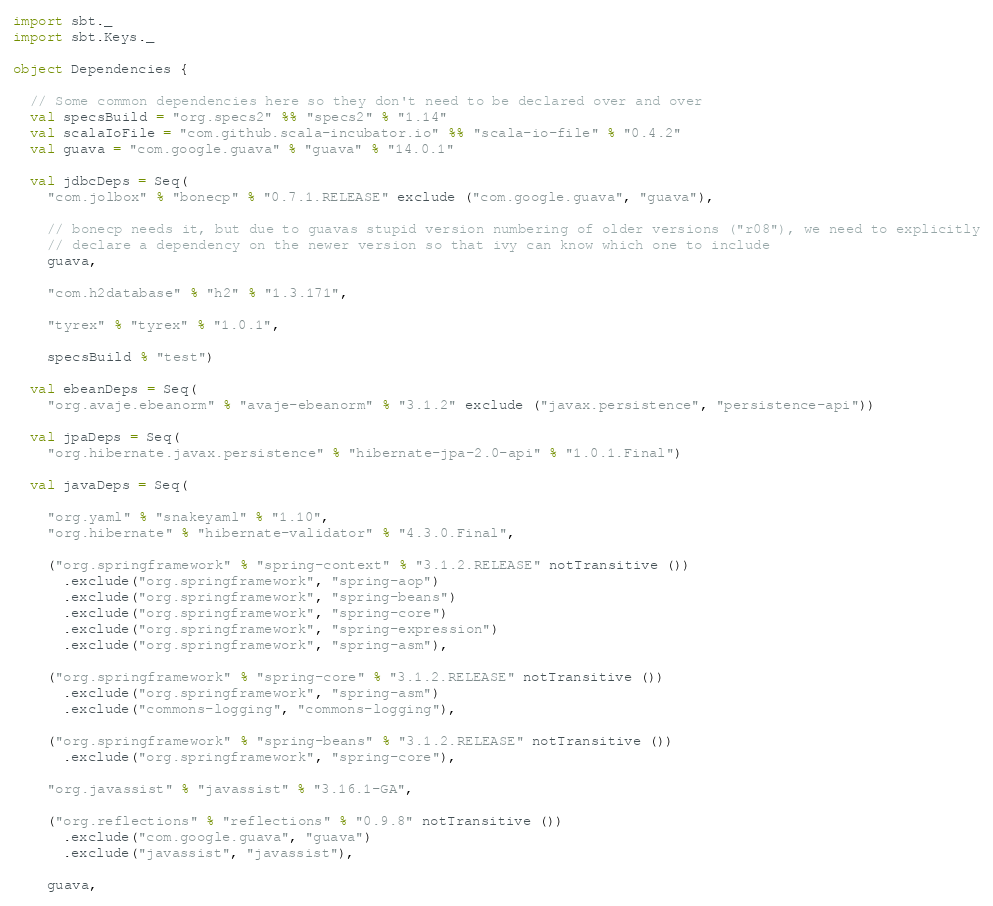Convert code to text. <code><loc_0><loc_0><loc_500><loc_500><_Scala_>import sbt._
import sbt.Keys._

object Dependencies {

  // Some common dependencies here so they don't need to be declared over and over
  val specsBuild = "org.specs2" %% "specs2" % "1.14"
  val scalaIoFile = "com.github.scala-incubator.io" %% "scala-io-file" % "0.4.2"
  val guava = "com.google.guava" % "guava" % "14.0.1"

  val jdbcDeps = Seq(
    "com.jolbox" % "bonecp" % "0.7.1.RELEASE" exclude ("com.google.guava", "guava"),

    // bonecp needs it, but due to guavas stupid version numbering of older versions ("r08"), we need to explicitly
    // declare a dependency on the newer version so that ivy can know which one to include
    guava,

    "com.h2database" % "h2" % "1.3.171",

    "tyrex" % "tyrex" % "1.0.1",

    specsBuild % "test")

  val ebeanDeps = Seq(
    "org.avaje.ebeanorm" % "avaje-ebeanorm" % "3.1.2" exclude ("javax.persistence", "persistence-api"))

  val jpaDeps = Seq(
    "org.hibernate.javax.persistence" % "hibernate-jpa-2.0-api" % "1.0.1.Final")

  val javaDeps = Seq(

    "org.yaml" % "snakeyaml" % "1.10",
    "org.hibernate" % "hibernate-validator" % "4.3.0.Final",

    ("org.springframework" % "spring-context" % "3.1.2.RELEASE" notTransitive ())
      .exclude("org.springframework", "spring-aop")
      .exclude("org.springframework", "spring-beans")
      .exclude("org.springframework", "spring-core")
      .exclude("org.springframework", "spring-expression")
      .exclude("org.springframework", "spring-asm"),

    ("org.springframework" % "spring-core" % "3.1.2.RELEASE" notTransitive ())
      .exclude("org.springframework", "spring-asm")
      .exclude("commons-logging", "commons-logging"),

    ("org.springframework" % "spring-beans" % "3.1.2.RELEASE" notTransitive ())
      .exclude("org.springframework", "spring-core"),

    "org.javassist" % "javassist" % "3.16.1-GA",

    ("org.reflections" % "reflections" % "0.9.8" notTransitive ())
      .exclude("com.google.guava", "guava")
      .exclude("javassist", "javassist"),

    guava,
</code> 